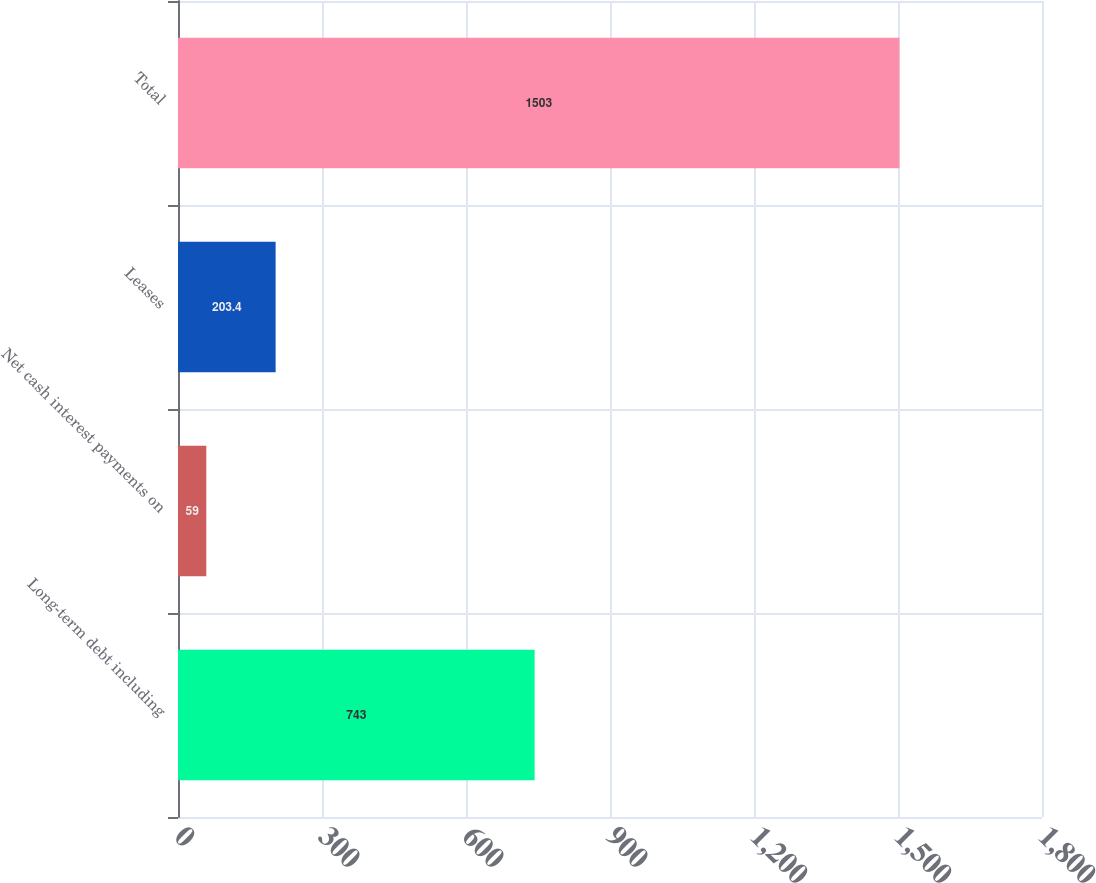Convert chart. <chart><loc_0><loc_0><loc_500><loc_500><bar_chart><fcel>Long-term debt including<fcel>Net cash interest payments on<fcel>Leases<fcel>Total<nl><fcel>743<fcel>59<fcel>203.4<fcel>1503<nl></chart> 